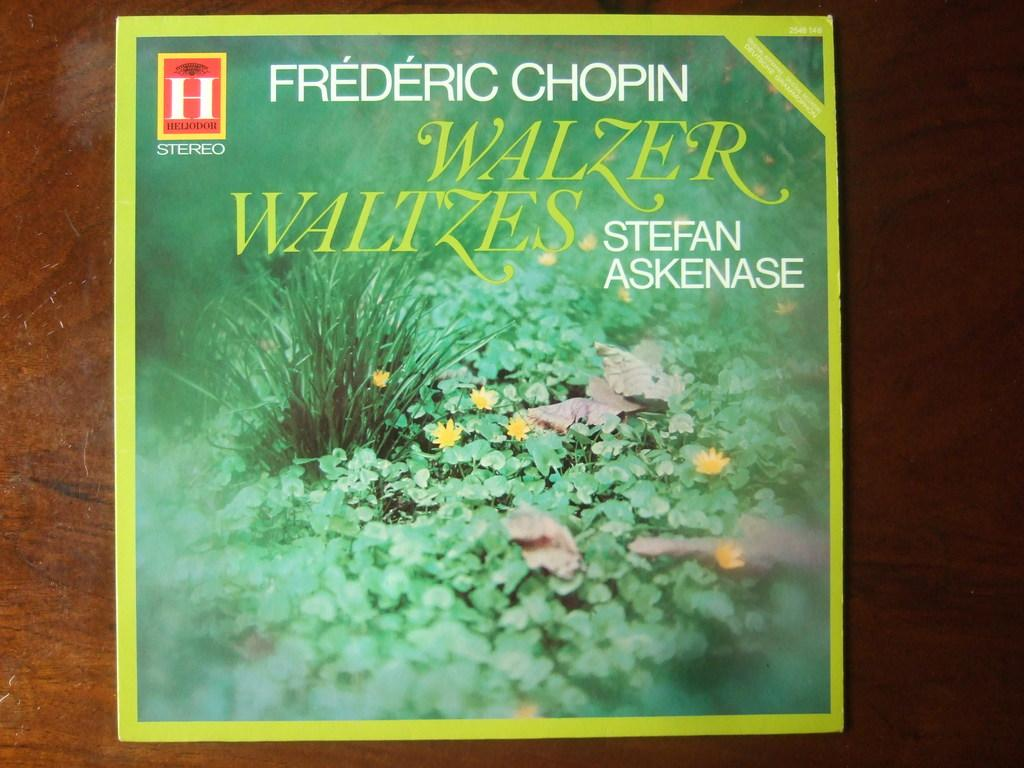<image>
Write a terse but informative summary of the picture. Frederic Chopin's Walzer Waltes are performed by Stefan Askenase on this album. 